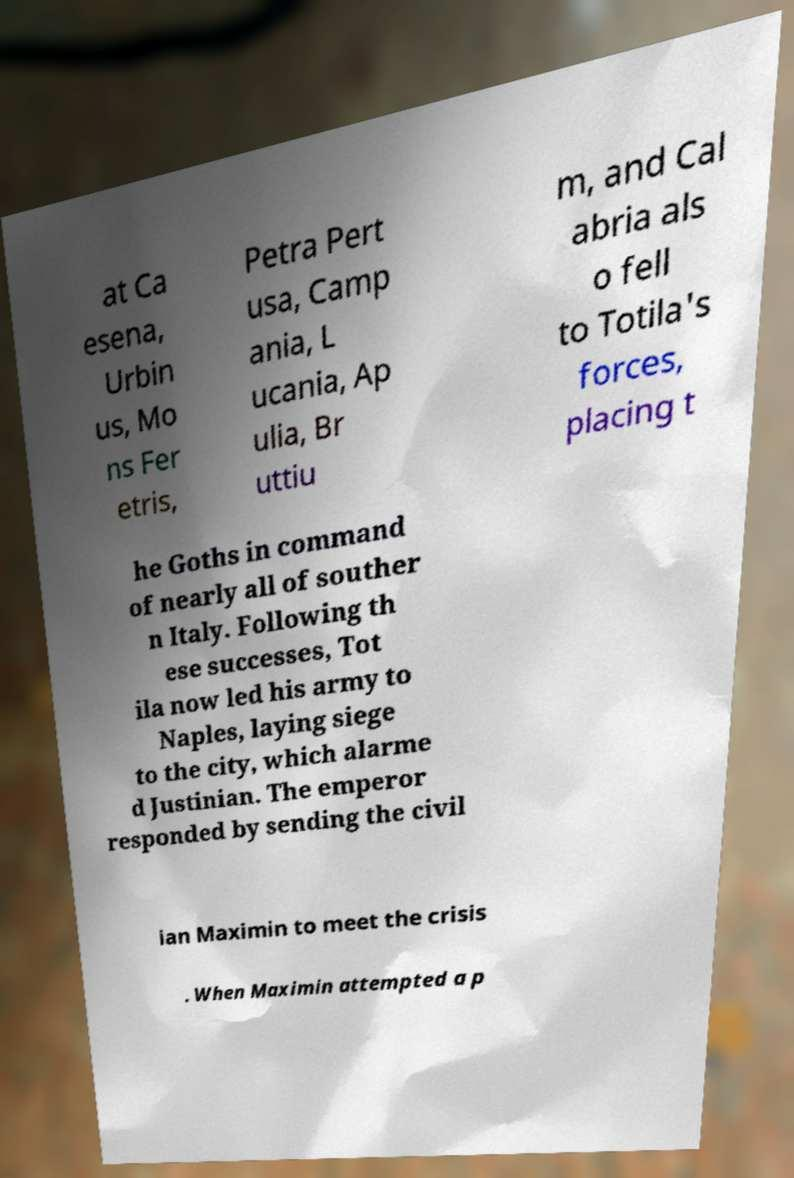Could you assist in decoding the text presented in this image and type it out clearly? at Ca esena, Urbin us, Mo ns Fer etris, Petra Pert usa, Camp ania, L ucania, Ap ulia, Br uttiu m, and Cal abria als o fell to Totila's forces, placing t he Goths in command of nearly all of souther n Italy. Following th ese successes, Tot ila now led his army to Naples, laying siege to the city, which alarme d Justinian. The emperor responded by sending the civil ian Maximin to meet the crisis . When Maximin attempted a p 